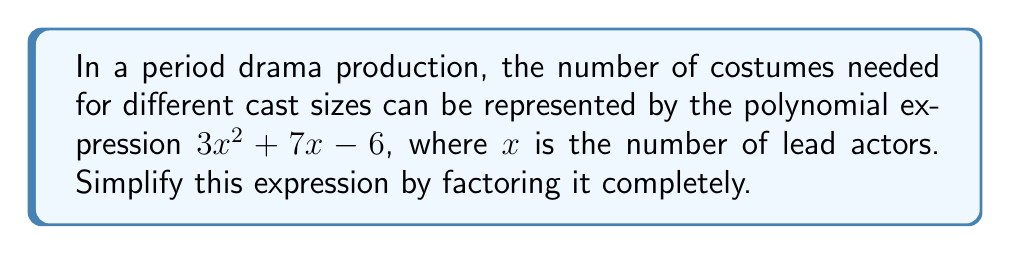Teach me how to tackle this problem. To factor this quadratic expression, we'll follow these steps:

1) First, identify the coefficients:
   $a = 3$, $b = 7$, and $c = -6$

2) We need to find two numbers that multiply to give $ac = 3 \times (-6) = -18$ and add up to $b = 7$. These numbers are 9 and -2.

3) Rewrite the middle term using these numbers:
   $3x^2 + 9x - 2x - 6$

4) Factor by grouping:
   $(3x^2 + 9x) + (-2x - 6)$
   $3x(x + 3) - 2(x + 3)$

5) Factor out the common factor $(x + 3)$:
   $(3x - 2)(x + 3)$

Thus, the factored form of $3x^2 + 7x - 6$ is $(3x - 2)(x + 3)$.
Answer: $(3x - 2)(x + 3)$ 